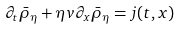Convert formula to latex. <formula><loc_0><loc_0><loc_500><loc_500>\partial _ { t } \bar { \rho } _ { \eta } + \eta v \partial _ { x } \bar { \rho } _ { \eta } = j ( t , x ) \,</formula> 